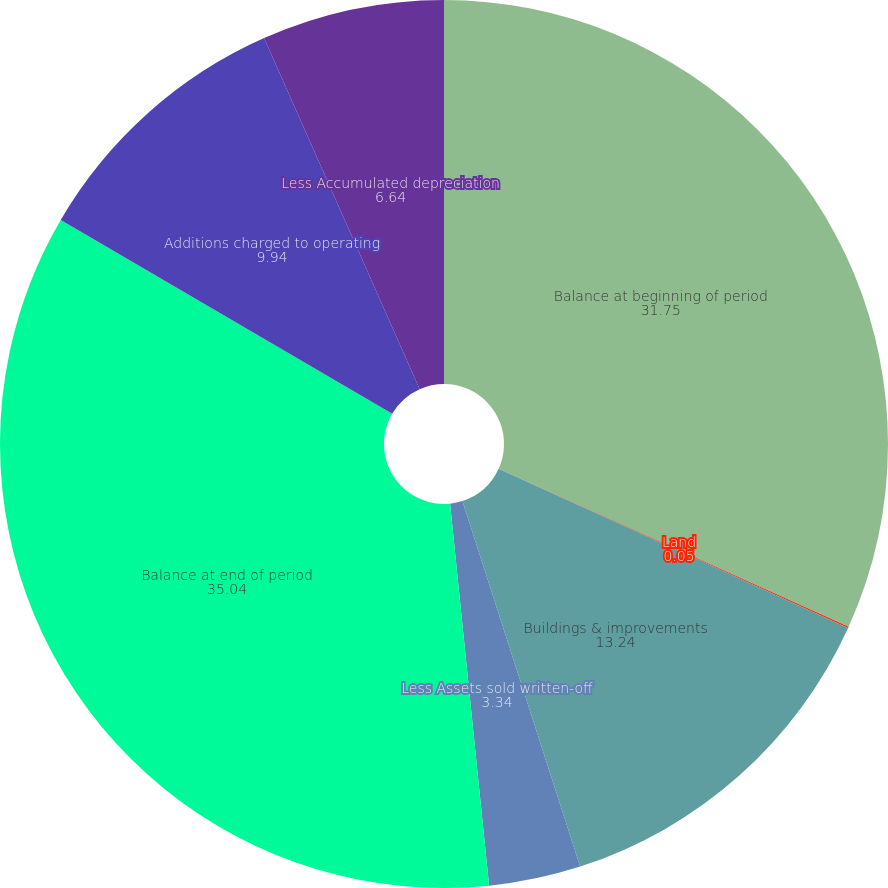Convert chart. <chart><loc_0><loc_0><loc_500><loc_500><pie_chart><fcel>Balance at beginning of period<fcel>Land<fcel>Buildings & improvements<fcel>Less Assets sold written-off<fcel>Balance at end of period<fcel>Additions charged to operating<fcel>Less Accumulated depreciation<nl><fcel>31.75%<fcel>0.05%<fcel>13.24%<fcel>3.34%<fcel>35.04%<fcel>9.94%<fcel>6.64%<nl></chart> 